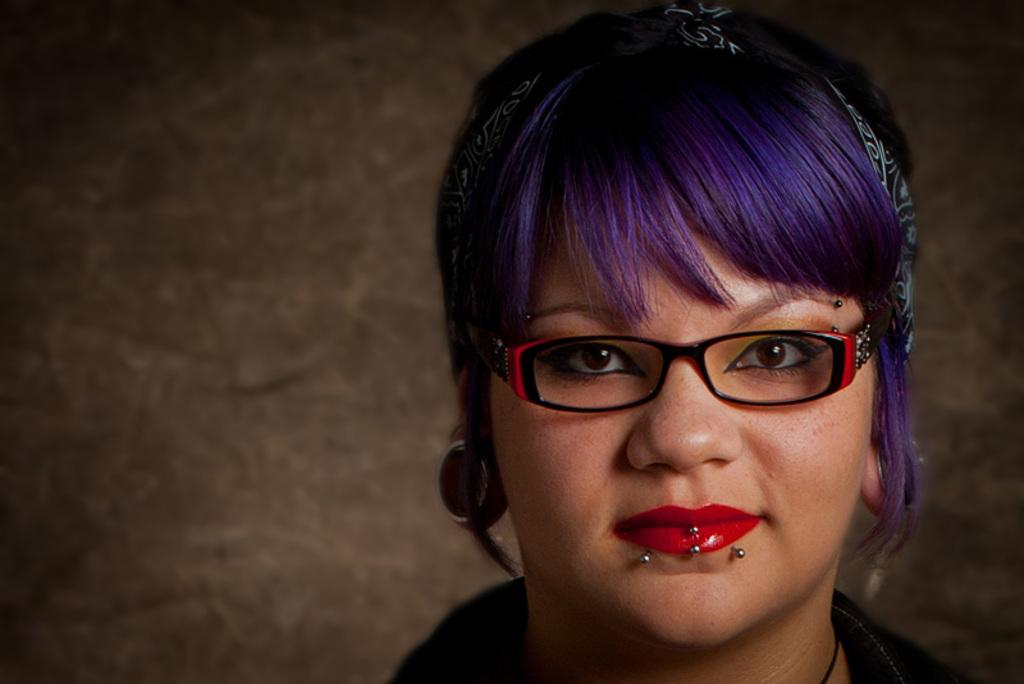What is the main subject of the image? The main subject of the image is a woman's head. What can be observed about the woman's appearance? The woman has red lipstick and purple hair. What is visible in the background of the image? There is a wall in the background of the image. How many toes can be seen on the woman's feet in the image? There are no feet or toes visible in the image, as it only shows the woman's head. What type of crate is present in the image? There is no crate present in the image; it only features the woman's head and a wall in the background. 